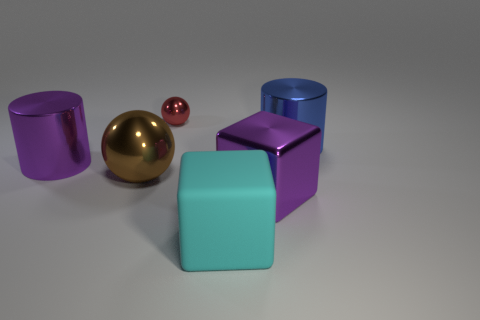Add 3 cylinders. How many objects exist? 9 Subtract all cylinders. How many objects are left? 4 Subtract all brown cubes. Subtract all tiny shiny objects. How many objects are left? 5 Add 6 cyan rubber things. How many cyan rubber things are left? 7 Add 2 big purple objects. How many big purple objects exist? 4 Subtract 0 cyan balls. How many objects are left? 6 